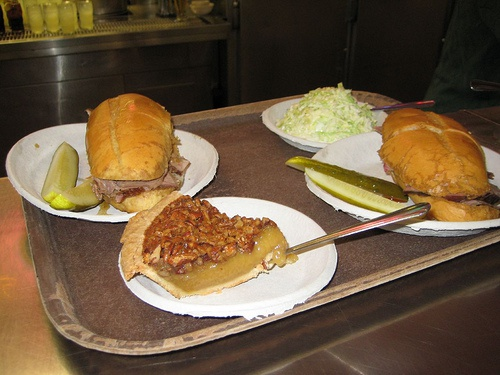Describe the objects in this image and their specific colors. I can see dining table in olive, maroon, and black tones, sandwich in olive, brown, and tan tones, sandwich in olive, orange, tan, and gray tones, sandwich in olive, orange, and maroon tones, and spoon in olive, gray, and tan tones in this image. 